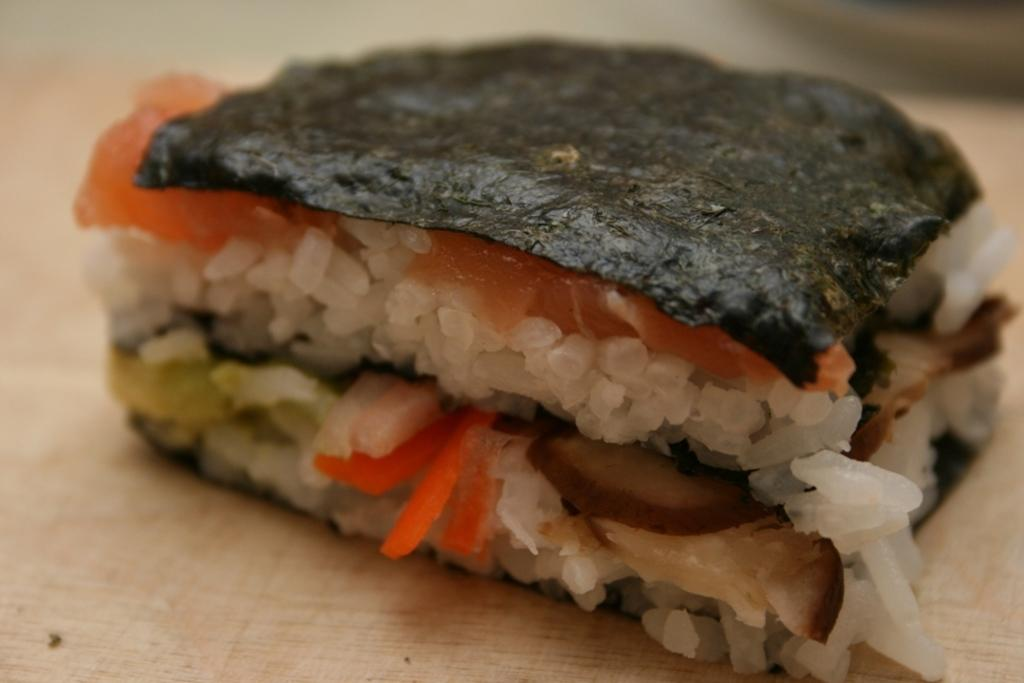What is present in the image? There is food in the image. Where is the food located? The food is on a platform. What type of jewel is being worn by the band in the image? There is no band or jewel present in the image; it only features food on a platform. 